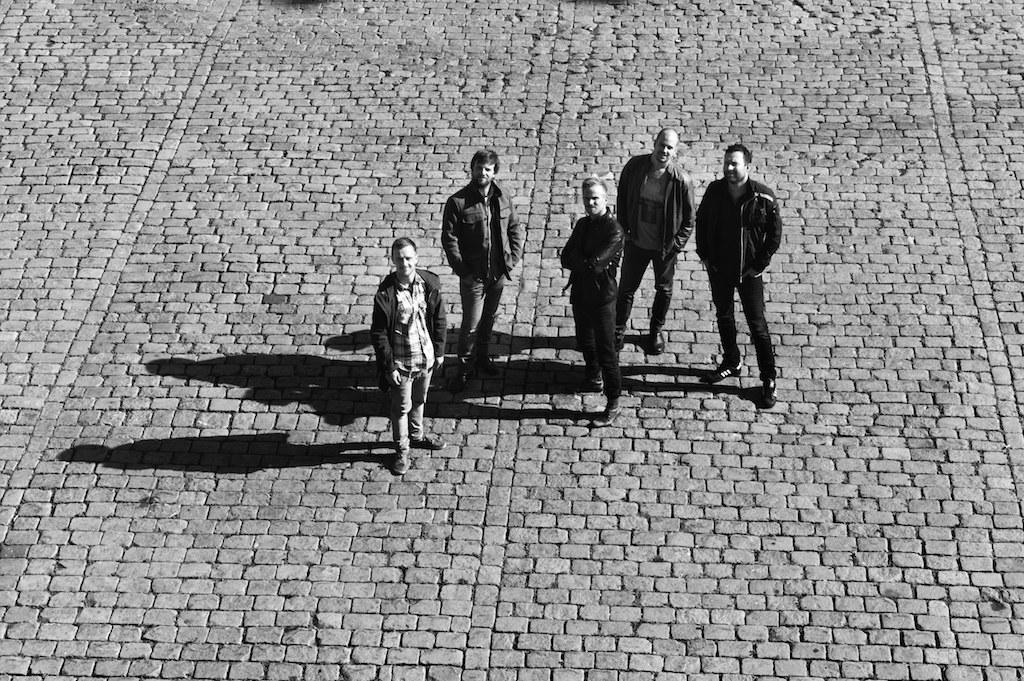In one or two sentences, can you explain what this image depicts? In this picture we can see a group of people, shadows on the ground. 